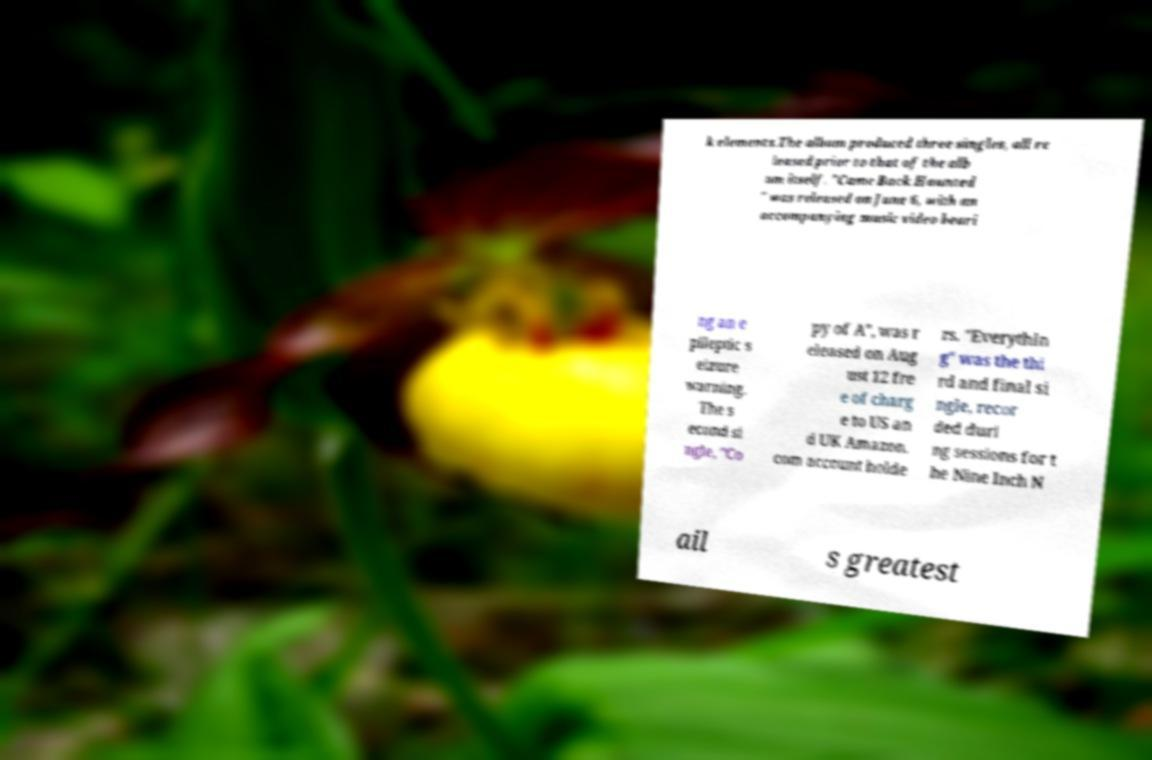Please identify and transcribe the text found in this image. k elements.The album produced three singles, all re leased prior to that of the alb um itself. "Came Back Haunted " was released on June 6, with an accompanying music video beari ng an e pileptic s eizure warning. The s econd si ngle, "Co py of A", was r eleased on Aug ust 12 fre e of charg e to US an d UK Amazon. com account holde rs. "Everythin g" was the thi rd and final si ngle, recor ded duri ng sessions for t he Nine Inch N ail s greatest 